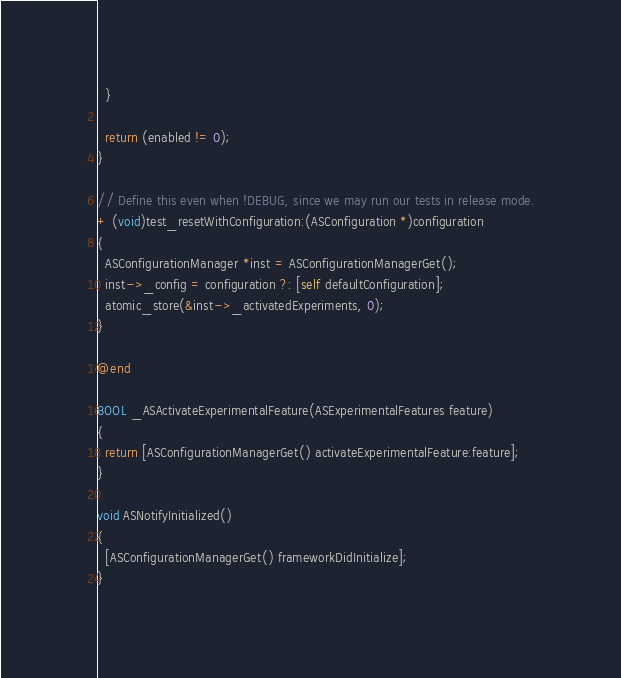<code> <loc_0><loc_0><loc_500><loc_500><_ObjectiveC_>  }
  
  return (enabled != 0);
}

// Define this even when !DEBUG, since we may run our tests in release mode.
+ (void)test_resetWithConfiguration:(ASConfiguration *)configuration
{
  ASConfigurationManager *inst = ASConfigurationManagerGet();
  inst->_config = configuration ?: [self defaultConfiguration];
  atomic_store(&inst->_activatedExperiments, 0);
}

@end

BOOL _ASActivateExperimentalFeature(ASExperimentalFeatures feature)
{
  return [ASConfigurationManagerGet() activateExperimentalFeature:feature];
}

void ASNotifyInitialized()
{
  [ASConfigurationManagerGet() frameworkDidInitialize];
}
</code> 